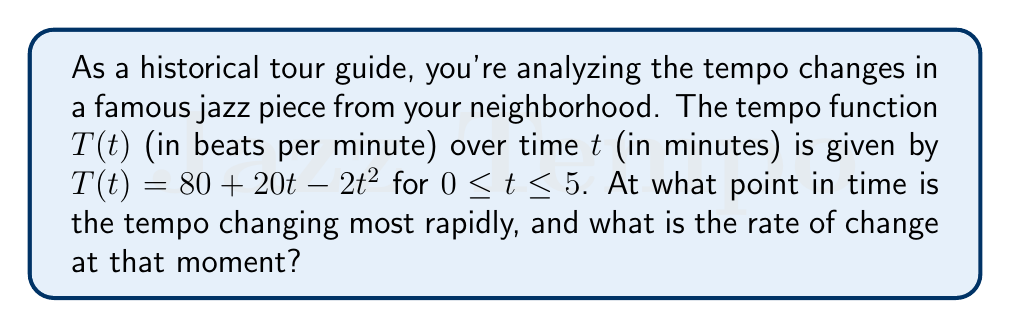Provide a solution to this math problem. To solve this problem, we need to use derivatives to analyze the rate of change of the tempo function.

1) First, let's find the first derivative of $T(t)$:
   $$T'(t) = 20 - 4t$$

   This represents the instantaneous rate of change of tempo at any given time $t$.

2) To find when the tempo is changing most rapidly, we need to find the maximum absolute value of $T'(t)$. Since $T'(t)$ is a linear function, its maximum absolute value will occur at one of the endpoints of the interval $[0, 5]$.

3) Let's evaluate $T'(t)$ at $t = 0$ and $t = 5$:
   
   At $t = 0$: $T'(0) = 20 - 4(0) = 20$
   At $t = 5$: $T'(5) = 20 - 4(5) = 0$

4) The absolute value is larger at $t = 0$, so the tempo is changing most rapidly at the beginning of the piece.

5) The rate of change at that moment is 20 beats per minute per minute, or 20 bpm/min.
Answer: The tempo is changing most rapidly at $t = 0$ minutes, with a rate of change of 20 bpm/min. 